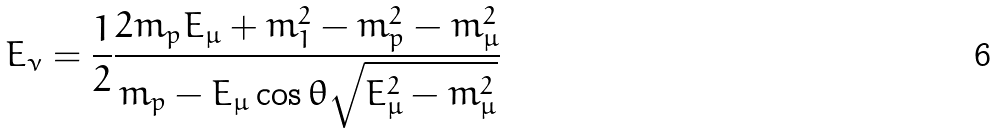<formula> <loc_0><loc_0><loc_500><loc_500>E _ { \nu } = \frac { 1 } { 2 } \frac { 2 m _ { p } E _ { \mu } + m _ { 1 } ^ { 2 } - m _ { p } ^ { 2 } - m _ { \mu } ^ { 2 } } { m _ { p } - E _ { \mu } \cos \theta \sqrt { E _ { \mu } ^ { 2 } - m _ { \mu } ^ { 2 } } }</formula> 